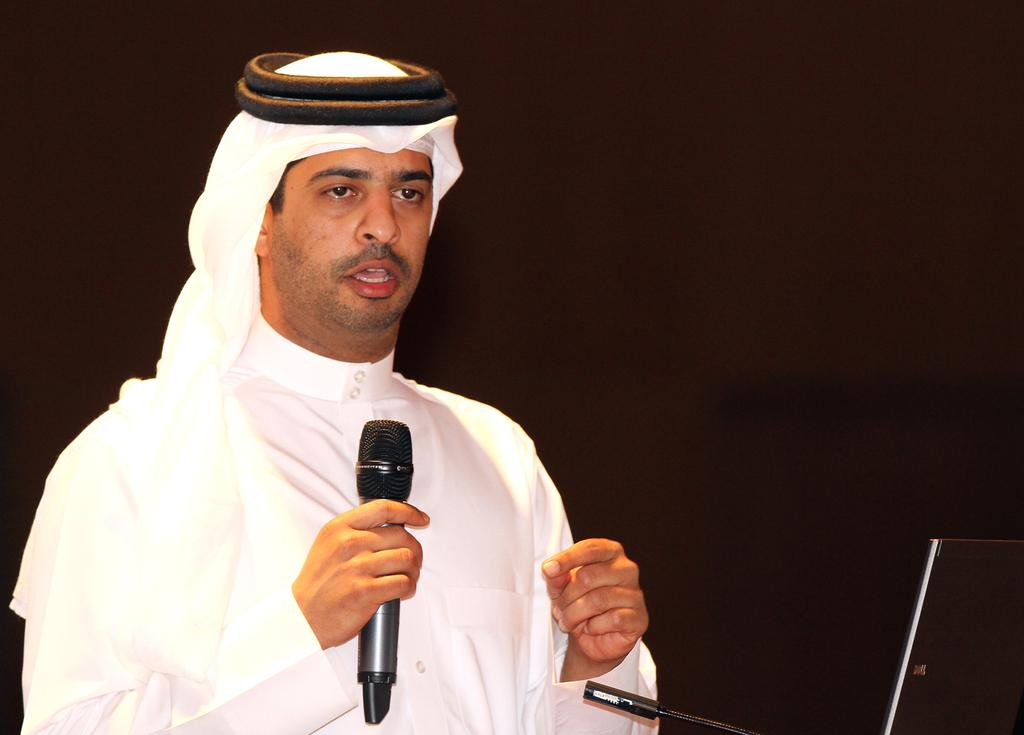What is the main subject of the image? There is a man in the image. What is the man doing in the image? The man is standing in the image. What object is the man holding in the image? The man is holding a microphone in the image. What type of linen can be seen draped over the microphone in the image? There is no linen draped over the microphone in the image. How many flies are buzzing around the man in the image? There are no flies present in the image. 